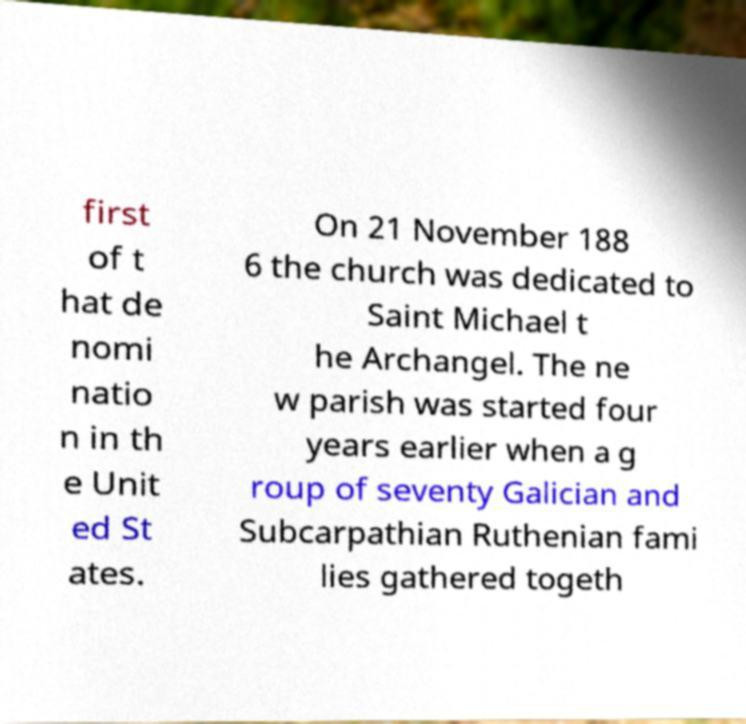I need the written content from this picture converted into text. Can you do that? first of t hat de nomi natio n in th e Unit ed St ates. On 21 November 188 6 the church was dedicated to Saint Michael t he Archangel. The ne w parish was started four years earlier when a g roup of seventy Galician and Subcarpathian Ruthenian fami lies gathered togeth 